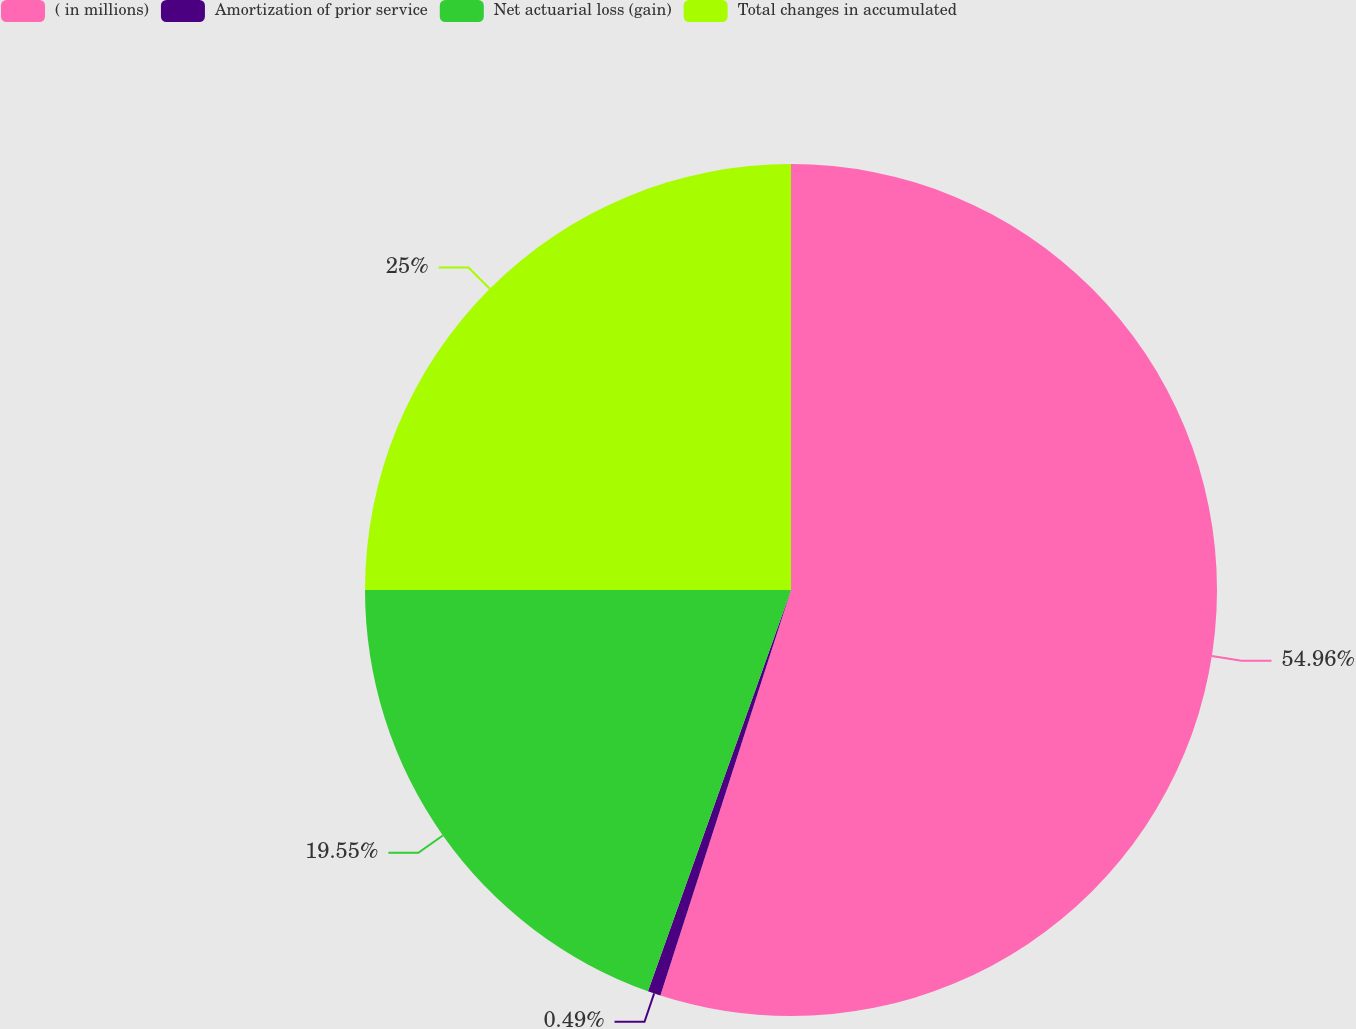Convert chart. <chart><loc_0><loc_0><loc_500><loc_500><pie_chart><fcel>( in millions)<fcel>Amortization of prior service<fcel>Net actuarial loss (gain)<fcel>Total changes in accumulated<nl><fcel>54.96%<fcel>0.49%<fcel>19.55%<fcel>25.0%<nl></chart> 